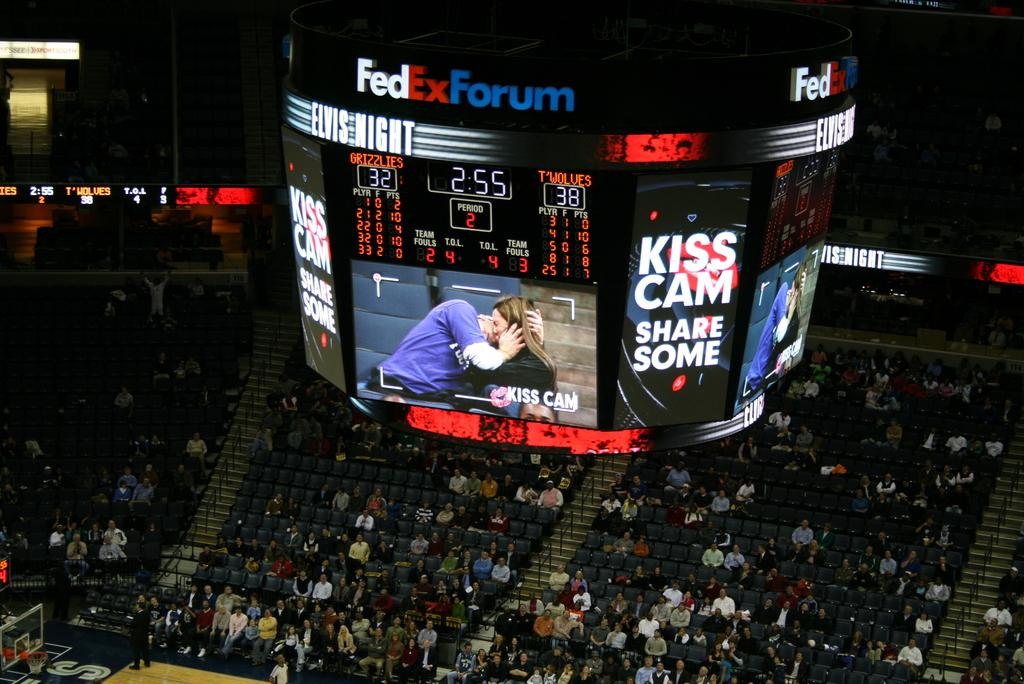<image>
Give a short and clear explanation of the subsequent image. The Kiss Cam is displaying on a large TV monitor at a stadium. 